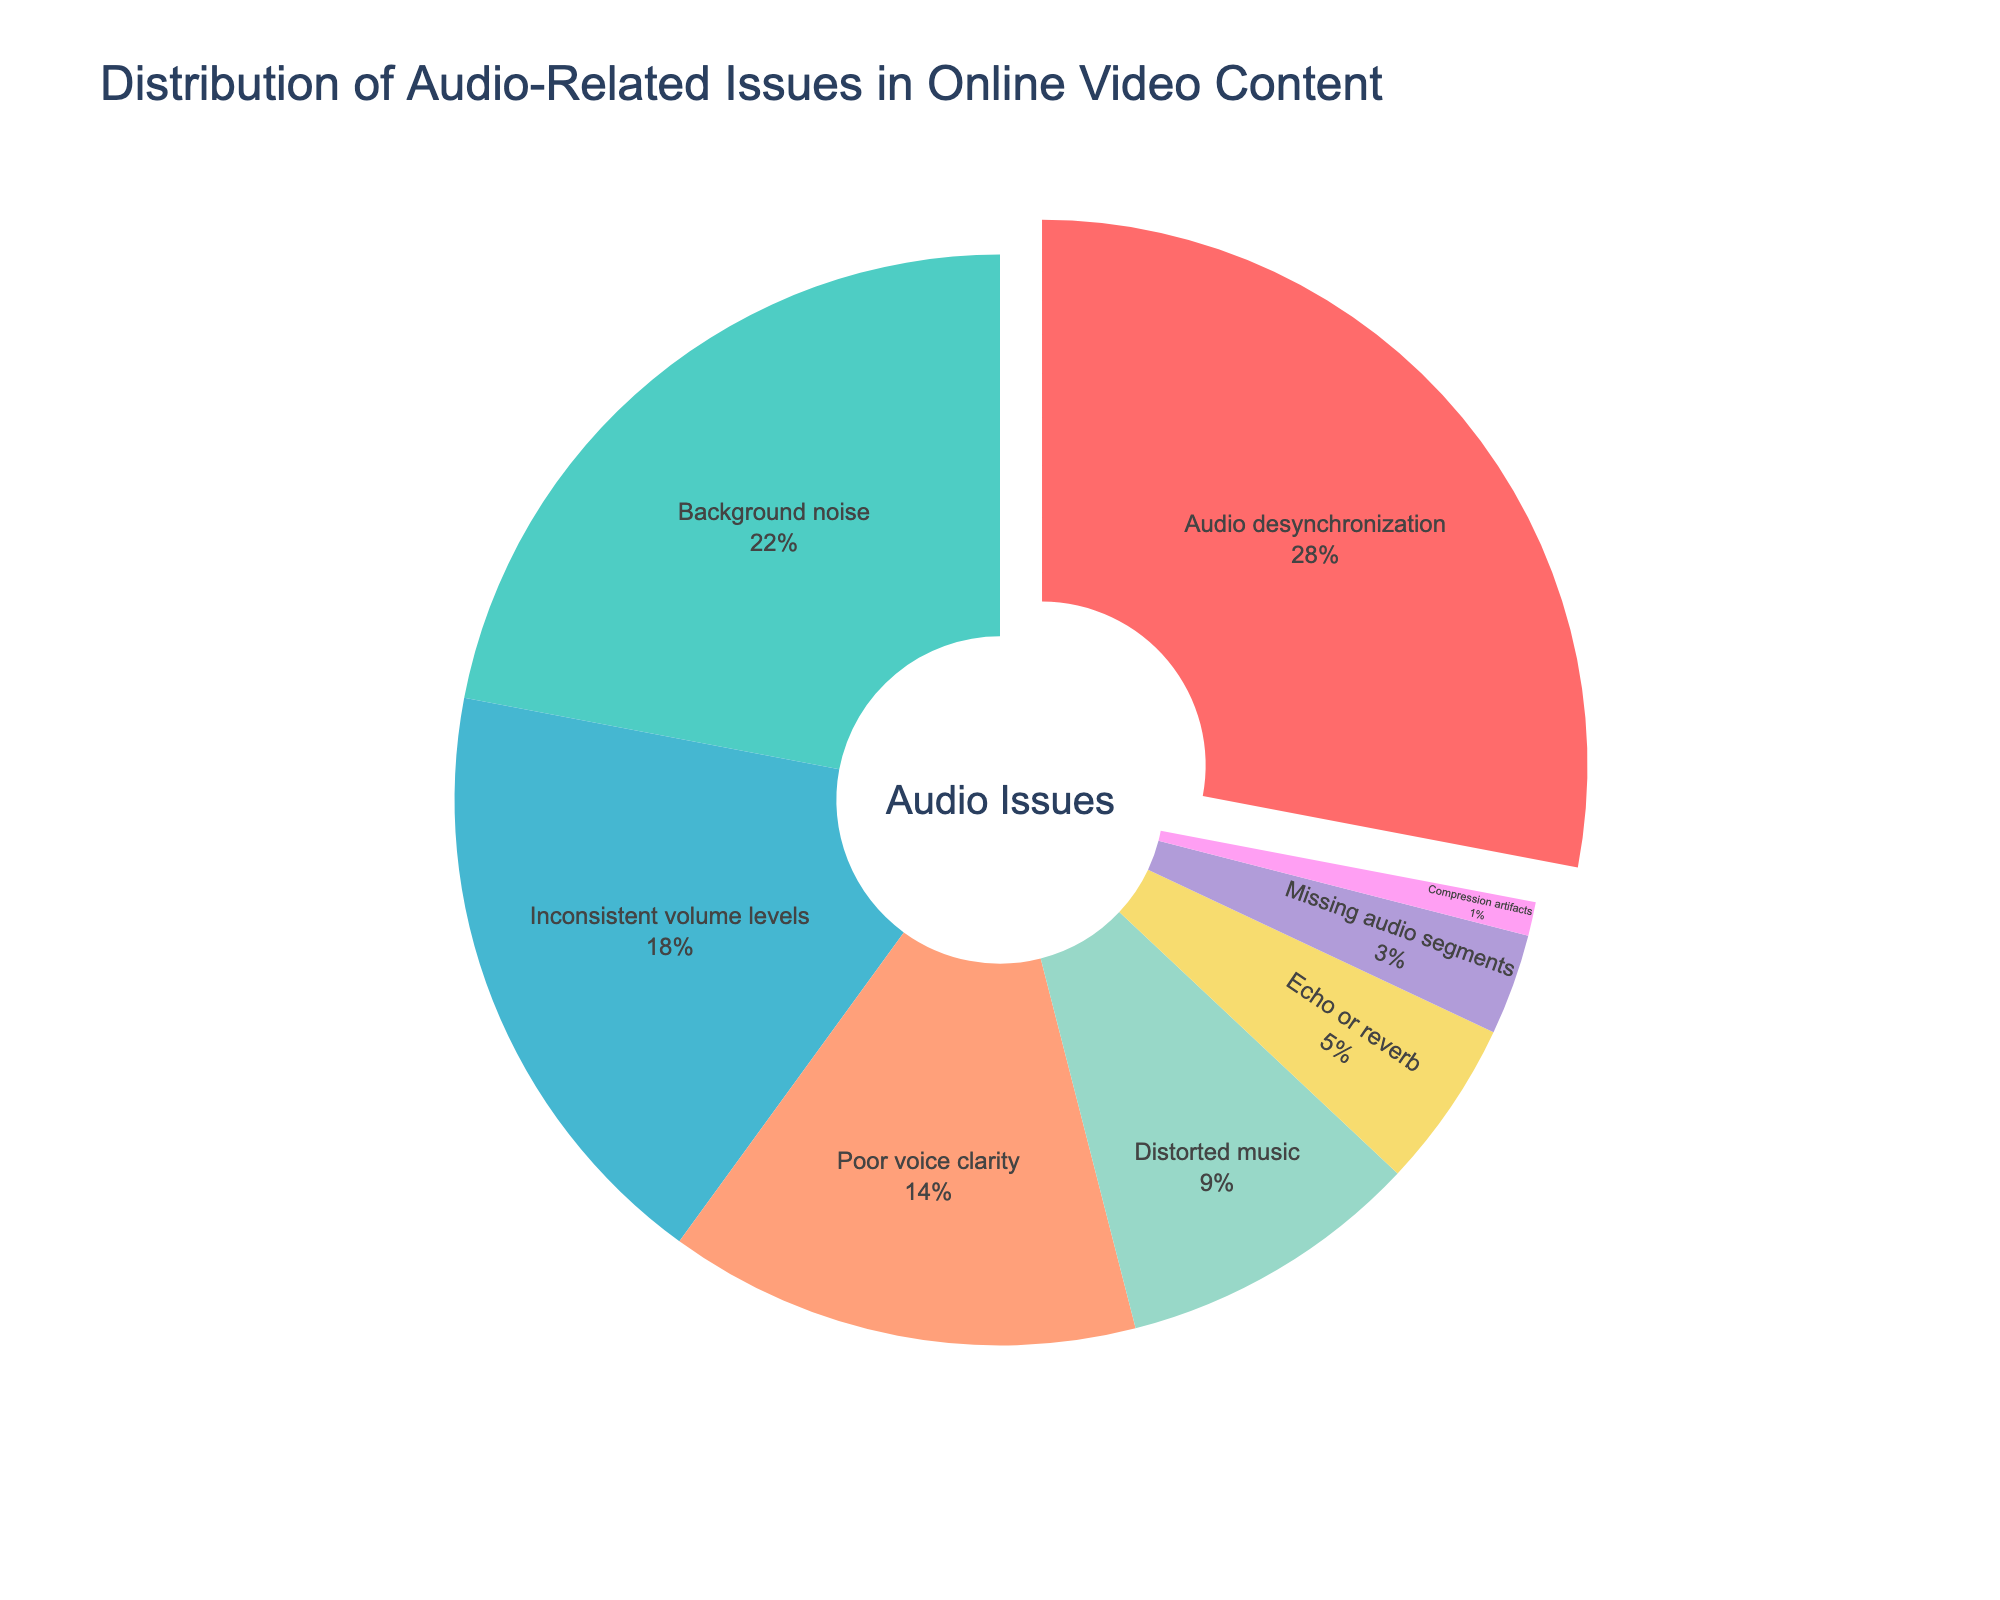Which category of audio-related issues is reported the most? The figure shows the highest percentage for "Audio desynchronization" at 28%, making it the most reported issue.
Answer: Audio desynchronization What is the combined percentage of "Poor voice clarity" and "Inconsistent volume levels"? Add the percentages of "Poor voice clarity" (14%) and "Inconsistent volume levels" (18%). 14 + 18 = 32%
Answer: 32% Which type of audio-related issue is more frequent: "Background noise" or "Distorted music"? Compare the percentages of "Background noise" (22%) and "Distorted music" (9%). "Background noise" has a higher percentage.
Answer: Background noise What is the least reported audio issue? The smallest percentage segment is for "Compression artifacts" at 1%.
Answer: Compression artifacts Are "Echo or reverb" occurrences more or less than half the occurrences of "Audio desynchronization"? "Echo or reverb" is 5% and "Audio desynchronization" is 28%. Calculate half of 28%, which equals 14%. Since 5% is less than 14%, "Echo or reverb" has fewer occurrences.
Answer: Less What is the difference in percentage between "Background noise" and "Poor voice clarity"? Subtract the percentage of "Poor voice clarity" (14%) from "Background noise" (22%). 22 - 14 = 8%
Answer: 8% Which section of the pie chart is colored in blue, and what percentage does it represent? The pie chart's section colored in blue represents "Distorted music" and it accounts for 9% of issues.
Answer: Distorted music, 9% What is the total percentage for issues related to volume (Inconsistent volume levels and Missing audio segments)? Add the percentages for "Inconsistent volume levels" (18%) and "Missing audio segments" (3%). 18 + 3 = 21%
Answer: 21% Which category has a percentage closest to the average percentage of all categories? The average percentage is the total sum of percentages (100%) divided by the number of categories (8). 100 / 8 = 12.5%. "Poor voice clarity" is 14%, which is the closest to 12.5%.
Answer: Poor voice clarity How much more frequent is "Audio desynchronization" compared to "Missing audio segments"? "Audio desynchronization" is 28% and "Missing audio segments" is 3%. Subtract 3 from 28 to find the difference, 28 - 3 = 25%.
Answer: 25% 